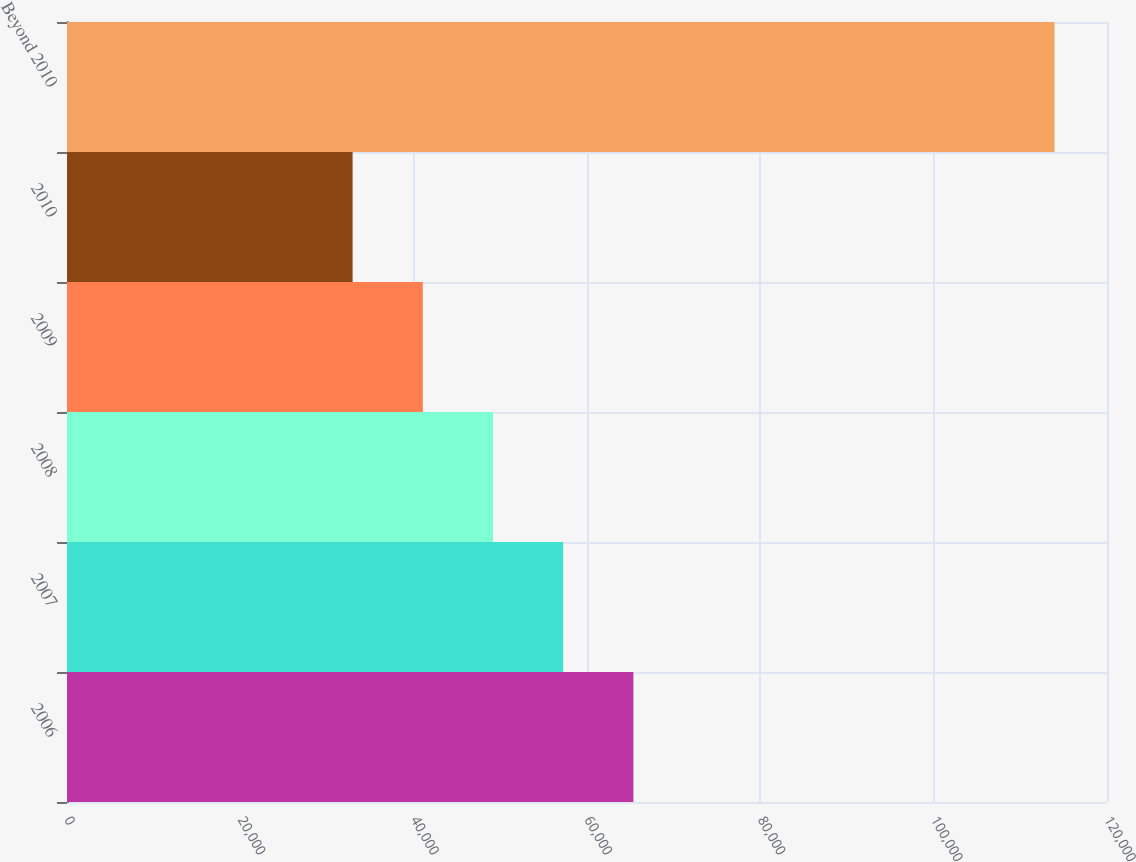<chart> <loc_0><loc_0><loc_500><loc_500><bar_chart><fcel>2006<fcel>2007<fcel>2008<fcel>2009<fcel>2010<fcel>Beyond 2010<nl><fcel>65350.6<fcel>57251.2<fcel>49151.8<fcel>41052.4<fcel>32953<fcel>113947<nl></chart> 